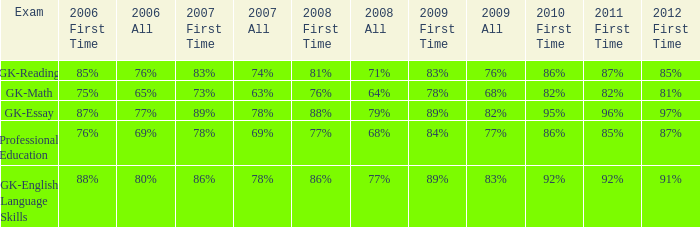What is the percentage for all in 2008 when all in 2007 was 69%? 68%. 